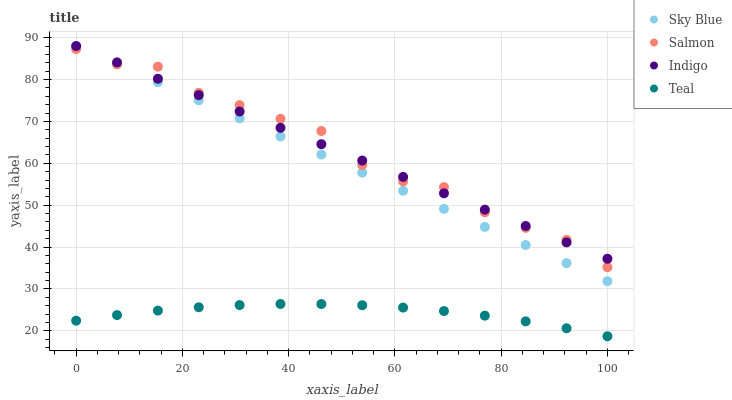Does Teal have the minimum area under the curve?
Answer yes or no. Yes. Does Salmon have the maximum area under the curve?
Answer yes or no. Yes. Does Salmon have the minimum area under the curve?
Answer yes or no. No. Does Teal have the maximum area under the curve?
Answer yes or no. No. Is Indigo the smoothest?
Answer yes or no. Yes. Is Salmon the roughest?
Answer yes or no. Yes. Is Teal the smoothest?
Answer yes or no. No. Is Teal the roughest?
Answer yes or no. No. Does Teal have the lowest value?
Answer yes or no. Yes. Does Salmon have the lowest value?
Answer yes or no. No. Does Indigo have the highest value?
Answer yes or no. Yes. Does Salmon have the highest value?
Answer yes or no. No. Is Teal less than Indigo?
Answer yes or no. Yes. Is Salmon greater than Teal?
Answer yes or no. Yes. Does Indigo intersect Salmon?
Answer yes or no. Yes. Is Indigo less than Salmon?
Answer yes or no. No. Is Indigo greater than Salmon?
Answer yes or no. No. Does Teal intersect Indigo?
Answer yes or no. No. 